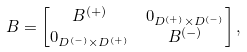<formula> <loc_0><loc_0><loc_500><loc_500>B & = \begin{bmatrix} B ^ { ( + ) } & 0 _ { D ^ { ( + ) } \times D ^ { ( - ) } } \\ 0 _ { D ^ { ( - ) } \times D ^ { ( + ) } } & B ^ { ( - ) } \end{bmatrix} ,</formula> 